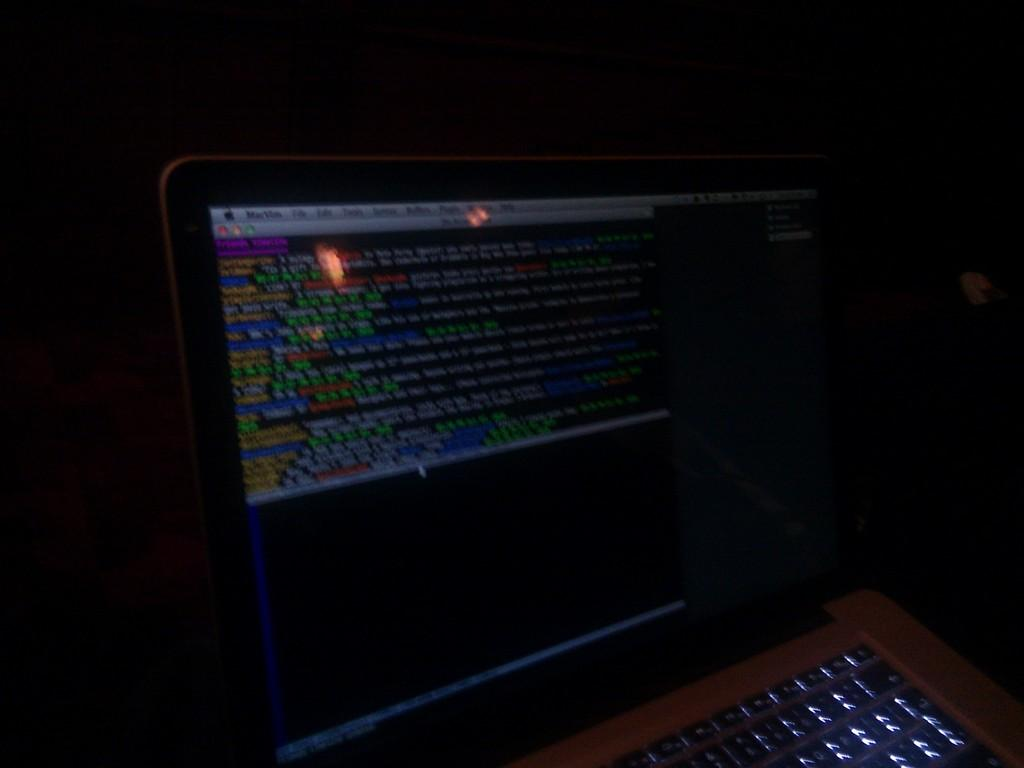What electronic device is present in the picture? There is a laptop in the picture. What is the state of the laptop in the image? The laptop is opened. What part of the laptop is visible in the image? The laptop's screen is visible. What can be seen on the laptop's screen? There is information displayed on the laptop's screen. How are the different pieces of information on the screen distinguished from one another? The information on the screen has different colors. What type of paint is being used to create the alarm on the laptop's screen? There is no paint or alarm present on the laptop's screen; it displays information with different colors. 